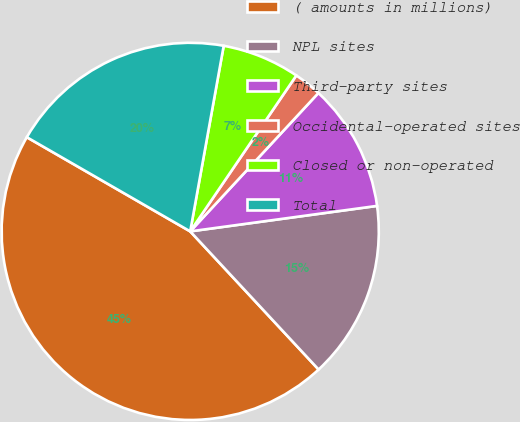<chart> <loc_0><loc_0><loc_500><loc_500><pie_chart><fcel>( amounts in millions)<fcel>NPL sites<fcel>Third-party sites<fcel>Occidental-operated sites<fcel>Closed or non-operated<fcel>Total<nl><fcel>45.24%<fcel>15.24%<fcel>10.95%<fcel>2.38%<fcel>6.67%<fcel>19.52%<nl></chart> 